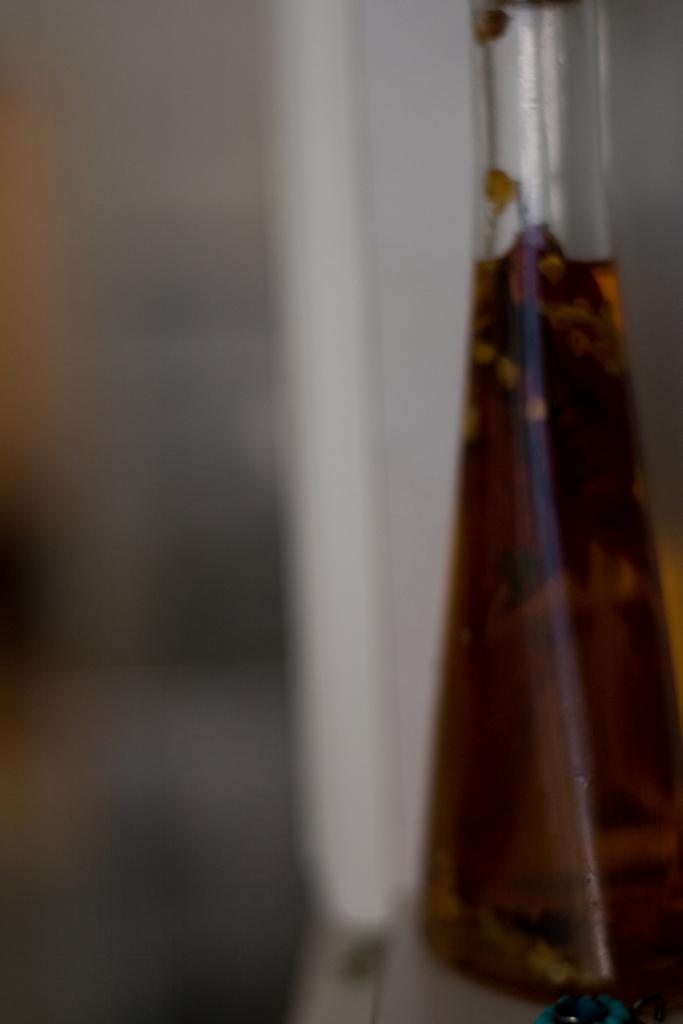Please provide a concise description of this image. In this image I can see a glass beaker with brown colored liquid in it on the white colored surface and I can see the blurry background. 